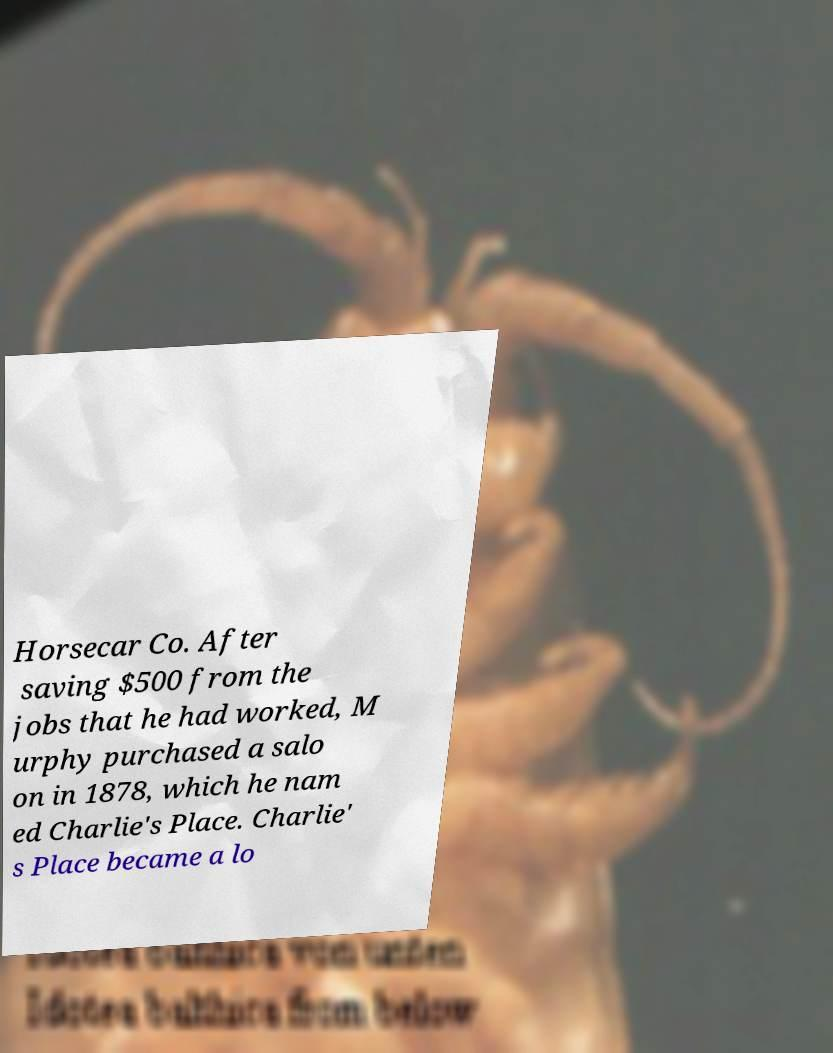Can you accurately transcribe the text from the provided image for me? Horsecar Co. After saving $500 from the jobs that he had worked, M urphy purchased a salo on in 1878, which he nam ed Charlie's Place. Charlie' s Place became a lo 